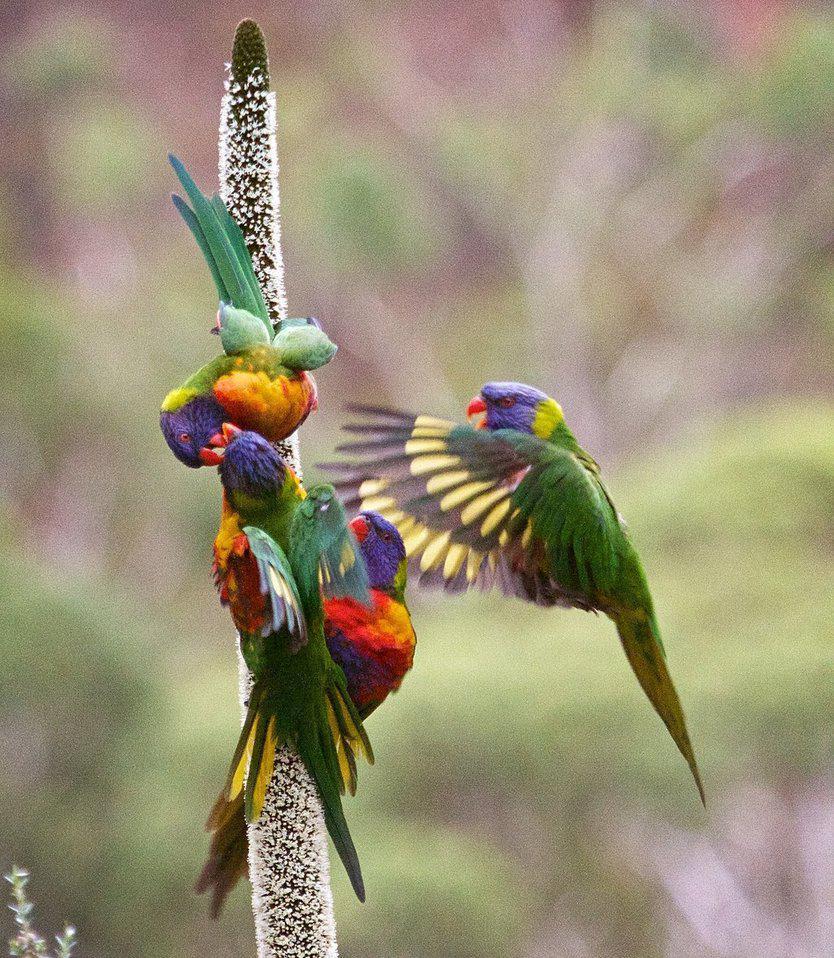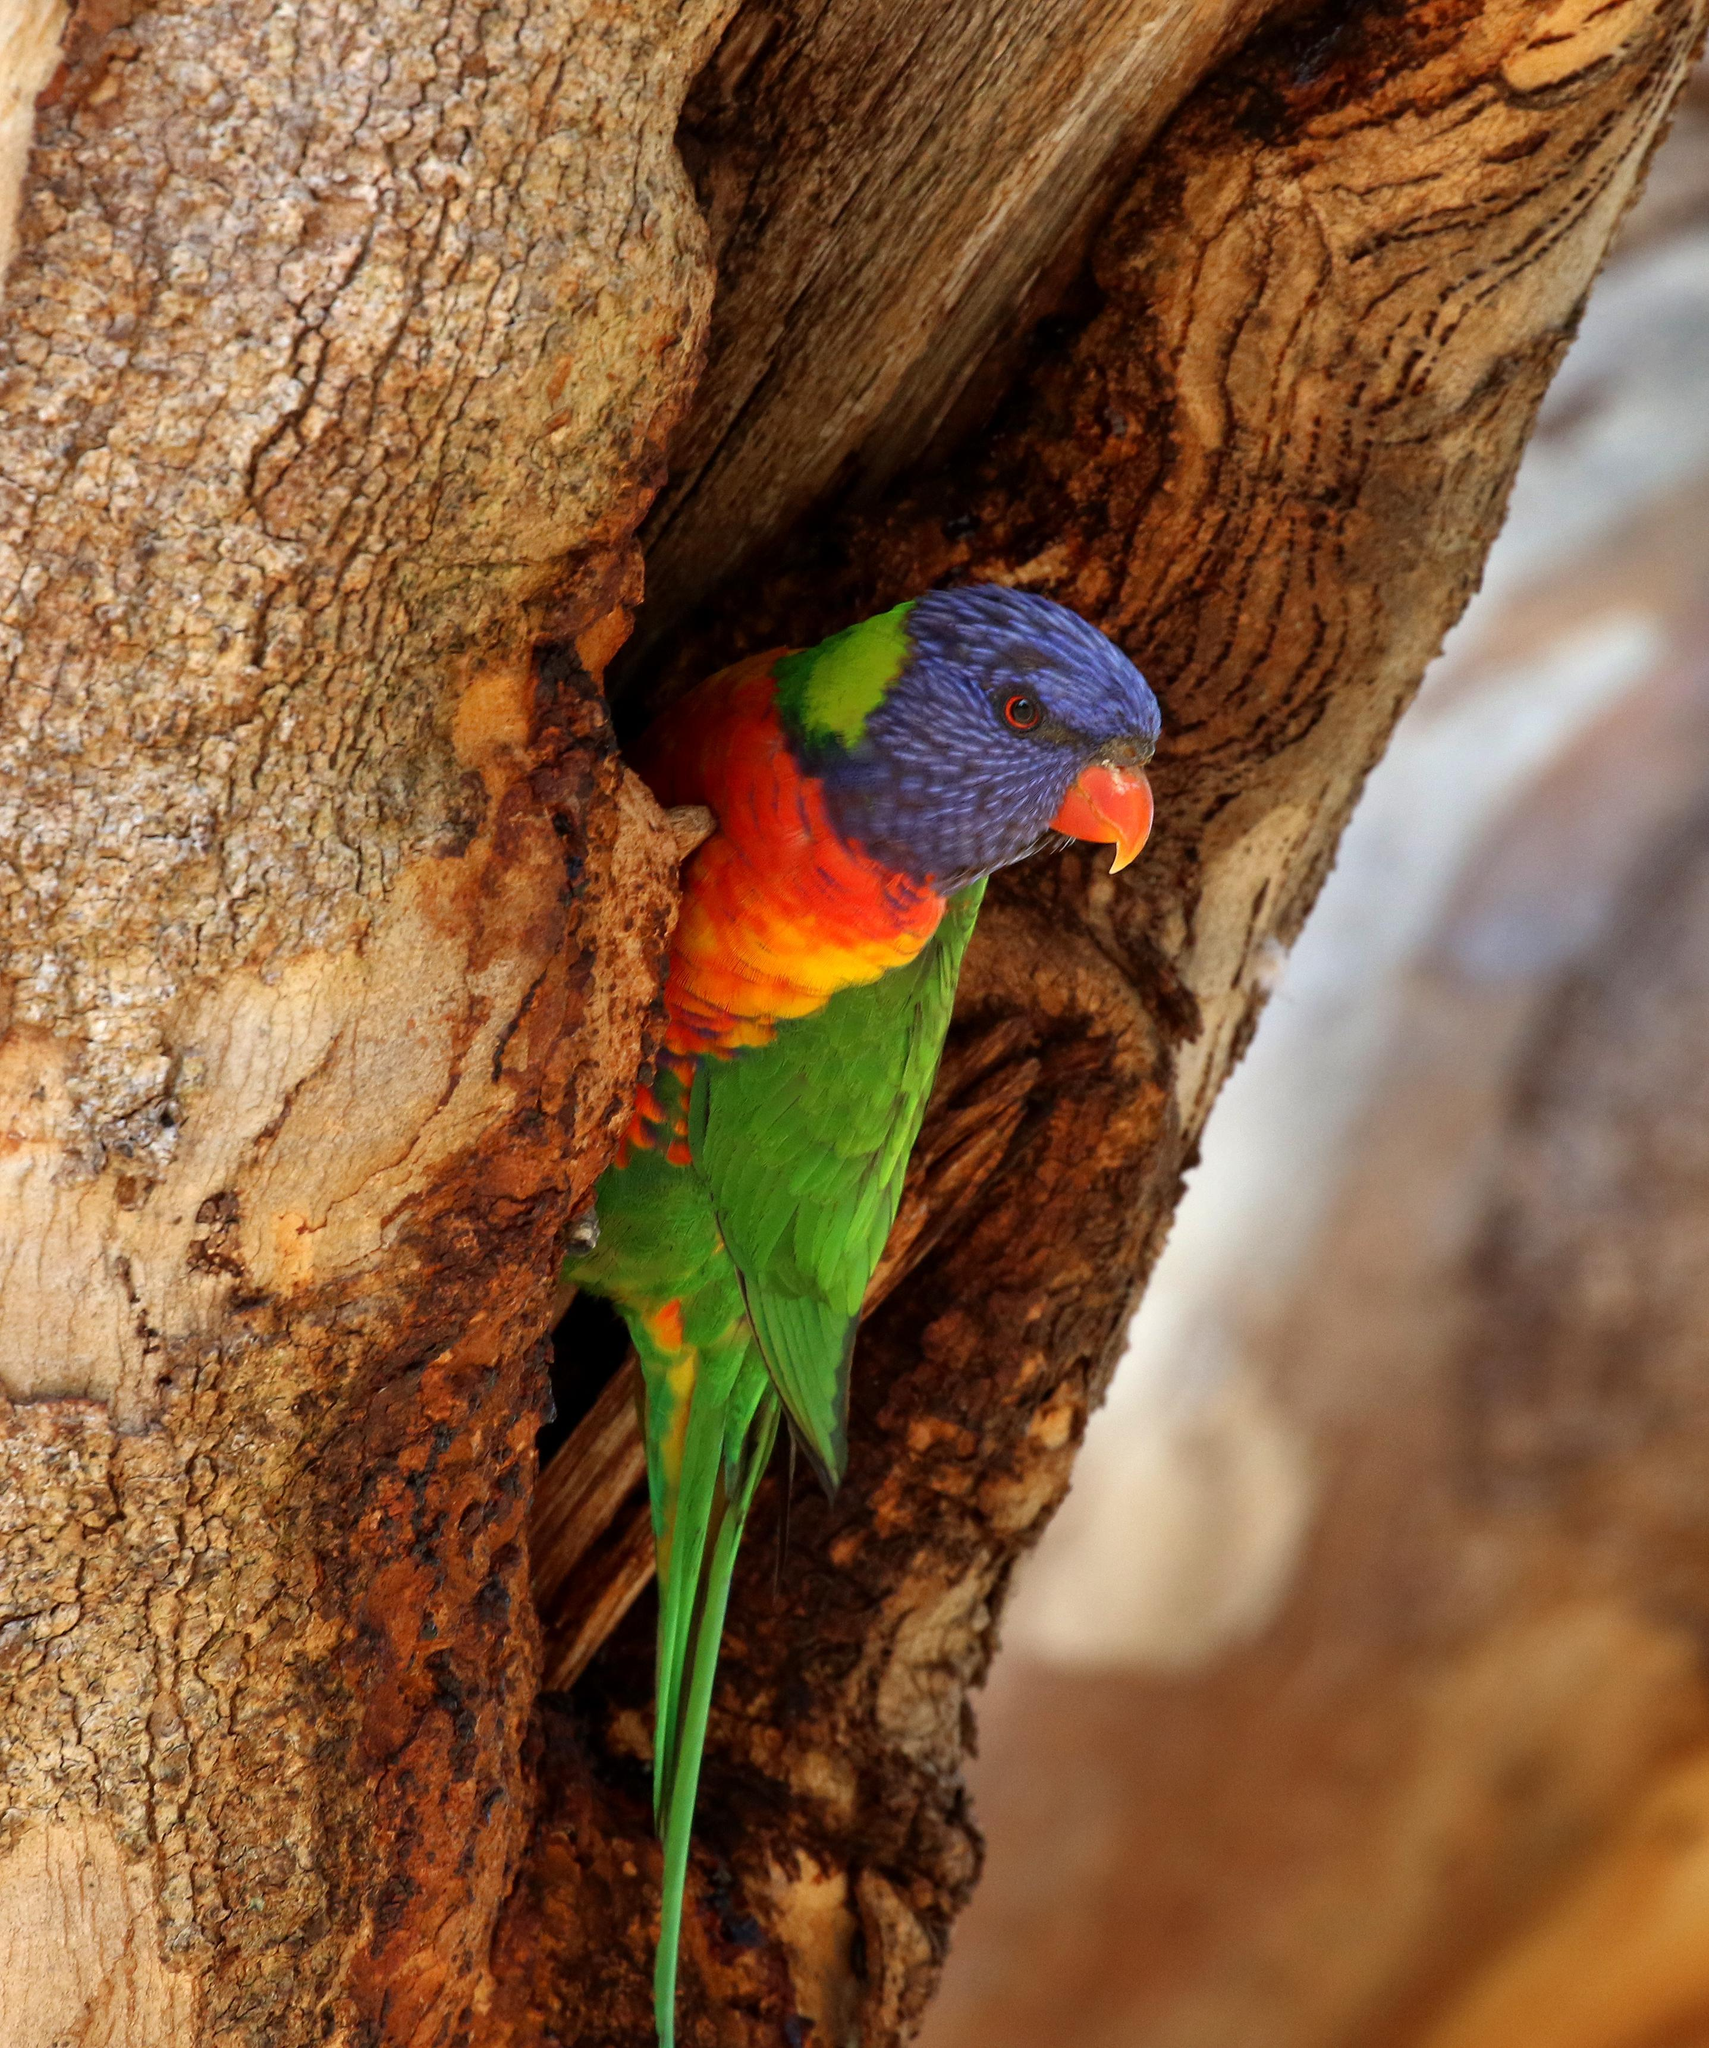The first image is the image on the left, the second image is the image on the right. Examine the images to the left and right. Is the description "In one of the images a colorful bird is sitting on a branch next to some bright pink flowers." accurate? Answer yes or no. No. The first image is the image on the left, the second image is the image on the right. Considering the images on both sides, is "An image contains a single colorful bird perched near hot pink flowers with tendril-like petals." valid? Answer yes or no. No. 